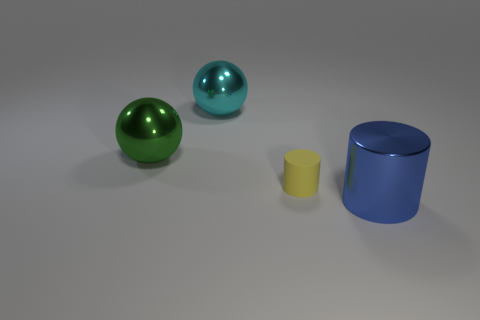Add 2 large cyan shiny objects. How many objects exist? 6 Subtract 1 cylinders. How many cylinders are left? 1 Add 1 tiny green metal things. How many tiny green metal things exist? 1 Subtract 0 brown cubes. How many objects are left? 4 Subtract all gray cylinders. Subtract all yellow blocks. How many cylinders are left? 2 Subtract all green metal spheres. Subtract all big green matte objects. How many objects are left? 3 Add 1 small yellow rubber cylinders. How many small yellow rubber cylinders are left? 2 